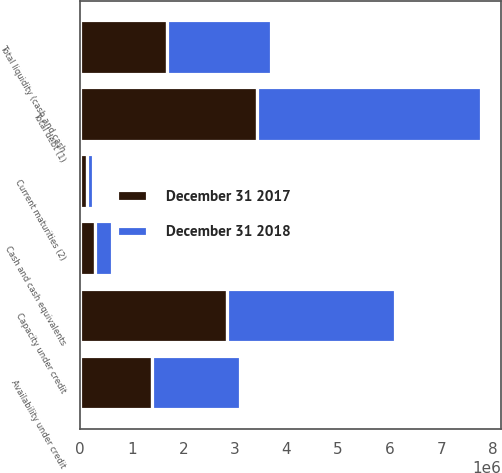Convert chart. <chart><loc_0><loc_0><loc_500><loc_500><stacked_bar_chart><ecel><fcel>Cash and cash equivalents<fcel>Total debt (1)<fcel>Current maturities (2)<fcel>Capacity under credit<fcel>Availability under credit<fcel>Total liquidity (cash and cash<nl><fcel>December 31 2018<fcel>331761<fcel>4.3477e+06<fcel>122117<fcel>3.26e+06<fcel>1.6977e+06<fcel>2.02946e+06<nl><fcel>December 31 2017<fcel>279766<fcel>3.42828e+06<fcel>129184<fcel>2.85e+06<fcel>1.39508e+06<fcel>1.67485e+06<nl></chart> 